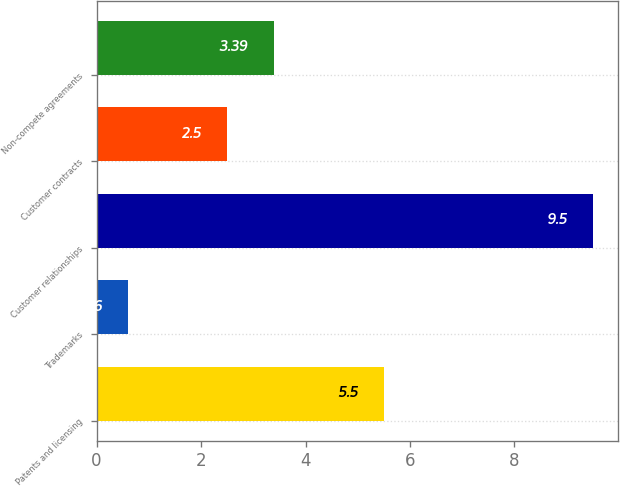Convert chart to OTSL. <chart><loc_0><loc_0><loc_500><loc_500><bar_chart><fcel>Patents and licensing<fcel>Trademarks<fcel>Customer relationships<fcel>Customer contracts<fcel>Non-compete agreements<nl><fcel>5.5<fcel>0.6<fcel>9.5<fcel>2.5<fcel>3.39<nl></chart> 